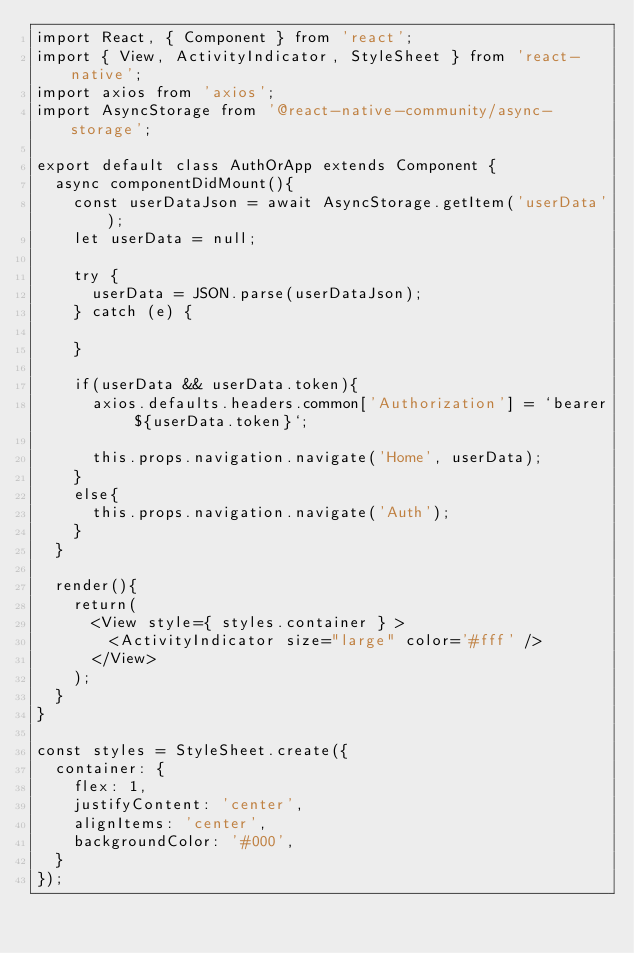<code> <loc_0><loc_0><loc_500><loc_500><_JavaScript_>import React, { Component } from 'react';
import { View, ActivityIndicator, StyleSheet } from 'react-native';
import axios from 'axios';
import AsyncStorage from '@react-native-community/async-storage';

export default class AuthOrApp extends Component {
  async componentDidMount(){
    const userDataJson = await AsyncStorage.getItem('userData');
    let userData = null;

    try {
      userData = JSON.parse(userDataJson);
    } catch (e) {
      
    }

    if(userData && userData.token){
      axios.defaults.headers.common['Authorization'] = `bearer ${userData.token}`;
      
      this.props.navigation.navigate('Home', userData);
    }
    else{
      this.props.navigation.navigate('Auth');
    }
  }

  render(){
    return(
      <View style={ styles.container } >
        <ActivityIndicator size="large" color='#fff' />
      </View>
    );
  }
}

const styles = StyleSheet.create({
  container: {
    flex: 1,
    justifyContent: 'center',
    alignItems: 'center',
    backgroundColor: '#000',
  }
});</code> 